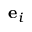Convert formula to latex. <formula><loc_0><loc_0><loc_500><loc_500>e _ { i }</formula> 